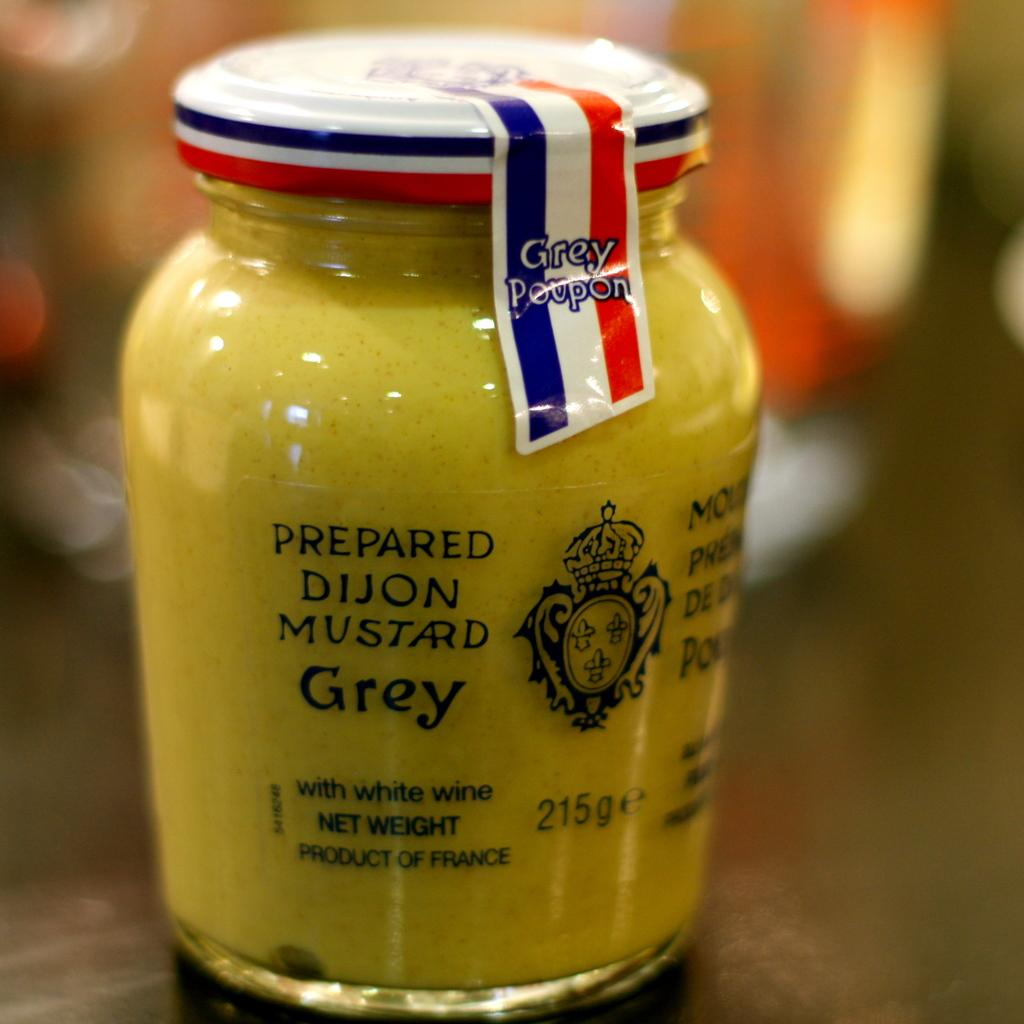<image>
Relay a brief, clear account of the picture shown. A jar of Grey Dijon Mustard weighs approximately 215g 